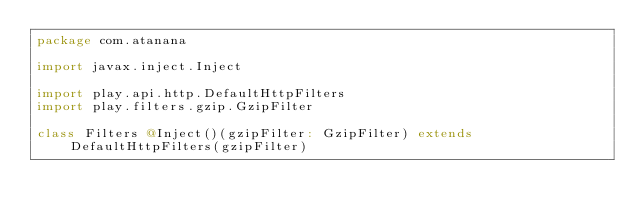<code> <loc_0><loc_0><loc_500><loc_500><_Scala_>package com.atanana

import javax.inject.Inject

import play.api.http.DefaultHttpFilters
import play.filters.gzip.GzipFilter

class Filters @Inject()(gzipFilter: GzipFilter) extends DefaultHttpFilters(gzipFilter)
</code> 